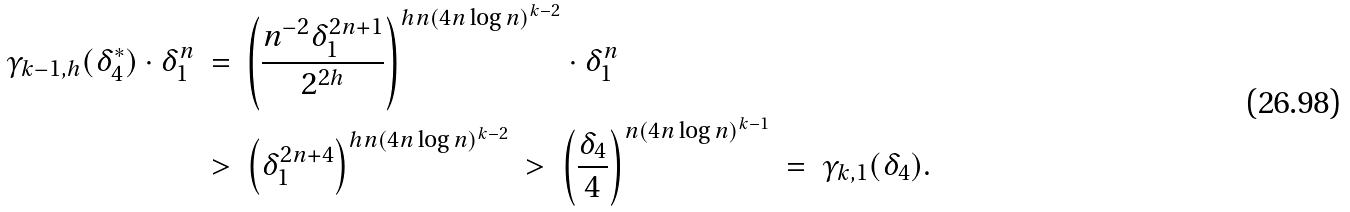<formula> <loc_0><loc_0><loc_500><loc_500>\gamma _ { k - 1 , h } ( \delta _ { 4 } ^ { * } ) \cdot \delta _ { 1 } ^ { n } \ & = \ \left ( \frac { n ^ { - 2 } \delta _ { 1 } ^ { 2 n + 1 } } { 2 ^ { 2 h } } \right ) ^ { h n ( 4 n \log n ) ^ { k - 2 } } \cdot \delta _ { 1 } ^ { n } \\ \ & > \ \left ( \delta _ { 1 } ^ { 2 n + 4 } \right ) ^ { h n ( 4 n \log n ) ^ { k - 2 } } \ > \ \left ( \frac { \delta _ { 4 } } { 4 } \right ) ^ { n ( 4 n \log n ) ^ { k - 1 } } \ = \ \gamma _ { k , 1 } ( \delta _ { 4 } ) .</formula> 